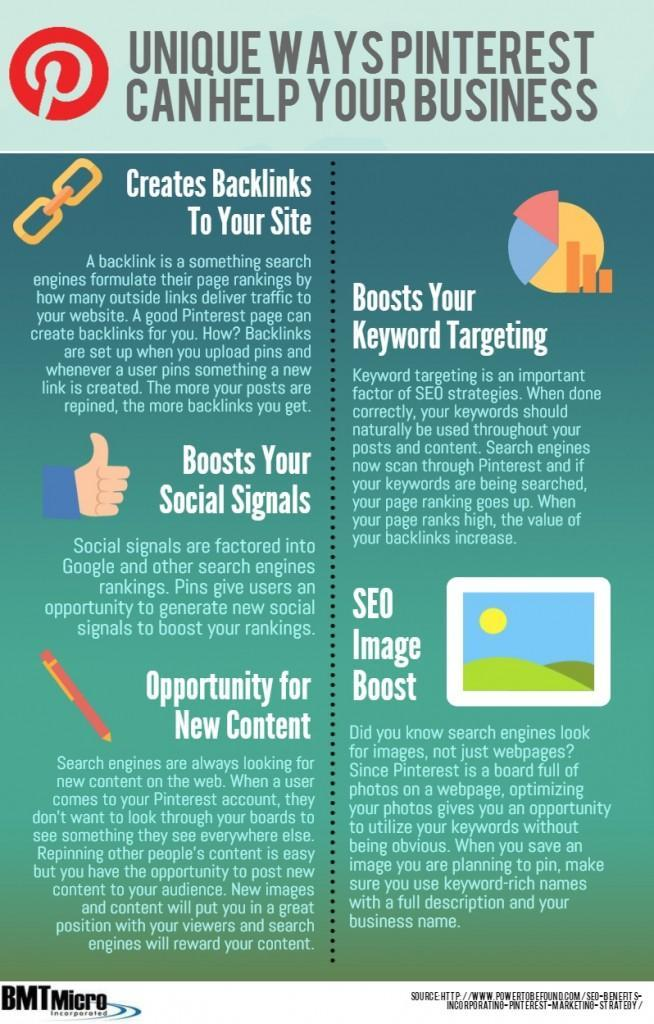How many ways can Pinterest helps businesses ?
Answer the question with a short phrase. 5 